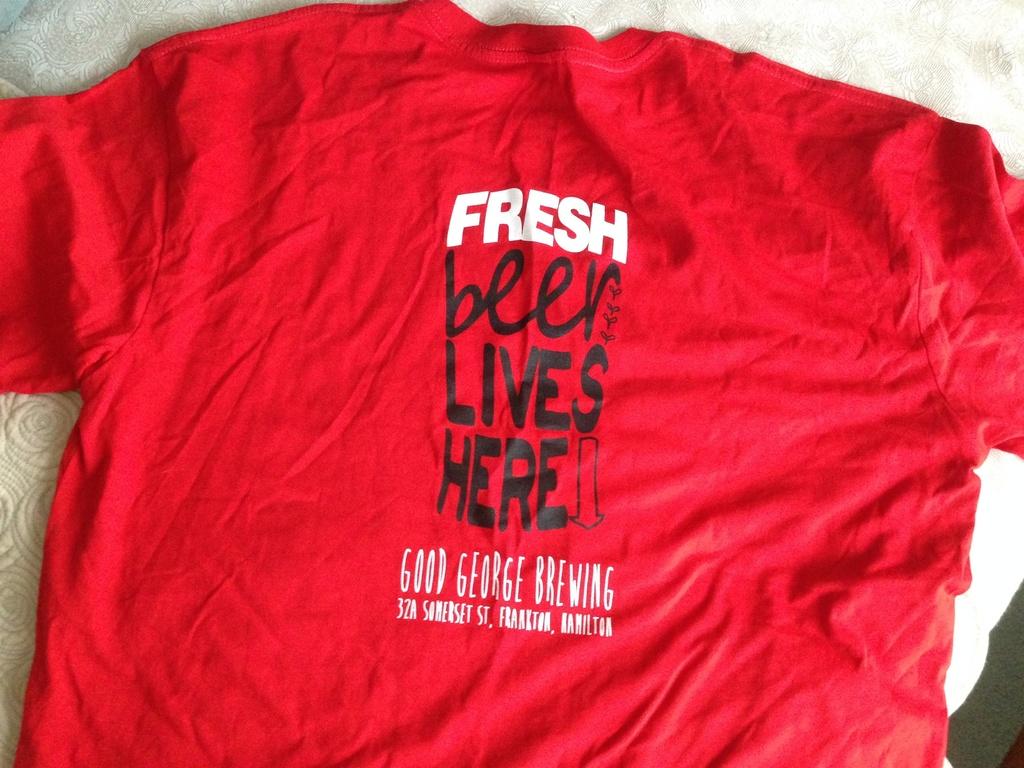This is tshirt?
Your answer should be very brief. Yes. This a cococala company?
Give a very brief answer. No. 